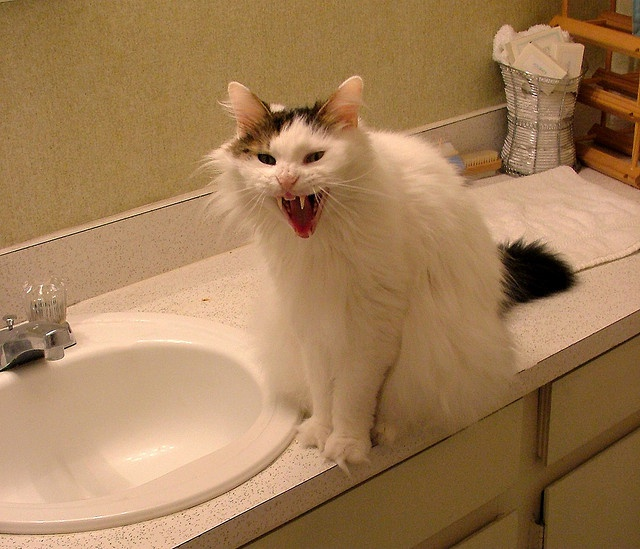Describe the objects in this image and their specific colors. I can see cat in olive, gray, and tan tones and sink in olive and tan tones in this image. 